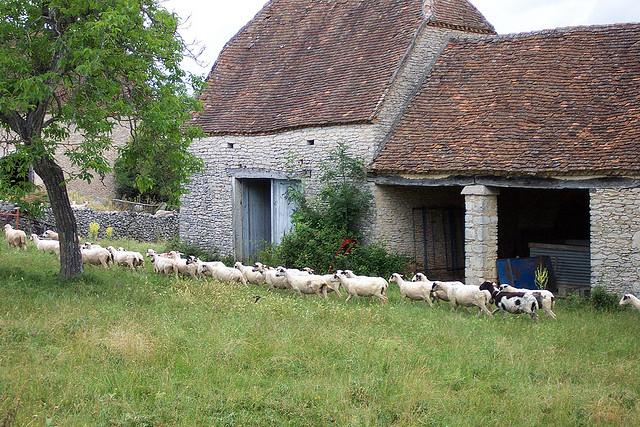Is the grass mowed?
Concise answer only. No. How many of the sheep are black and white?
Give a very brief answer. 1. What is the building made of?
Be succinct. Stone. 